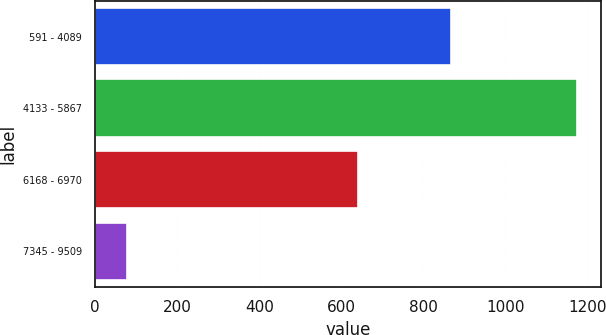Convert chart to OTSL. <chart><loc_0><loc_0><loc_500><loc_500><bar_chart><fcel>591 - 4089<fcel>4133 - 5867<fcel>6168 - 6970<fcel>7345 - 9509<nl><fcel>868<fcel>1175<fcel>641<fcel>78<nl></chart> 